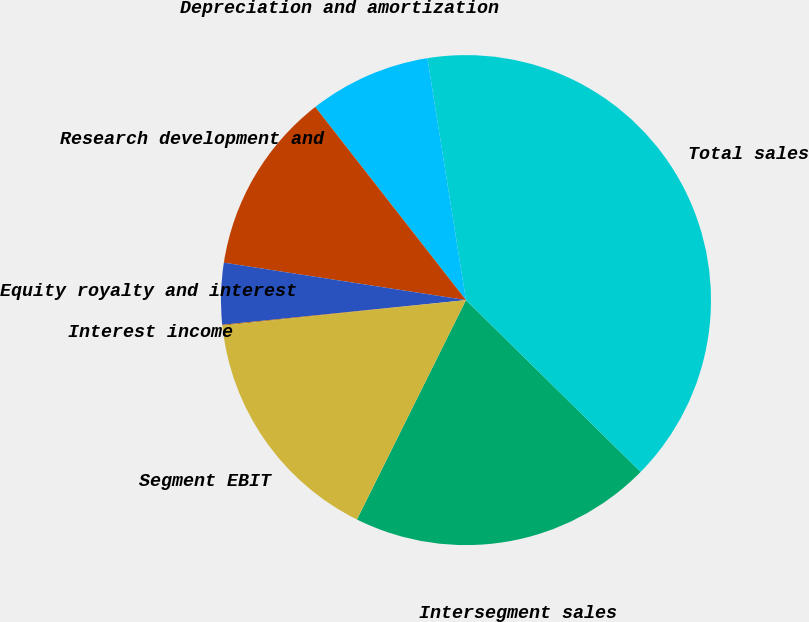<chart> <loc_0><loc_0><loc_500><loc_500><pie_chart><fcel>Intersegment sales<fcel>Total sales<fcel>Depreciation and amortization<fcel>Research development and<fcel>Equity royalty and interest<fcel>Interest income<fcel>Segment EBIT<nl><fcel>19.97%<fcel>39.89%<fcel>8.03%<fcel>12.01%<fcel>4.05%<fcel>0.06%<fcel>15.99%<nl></chart> 